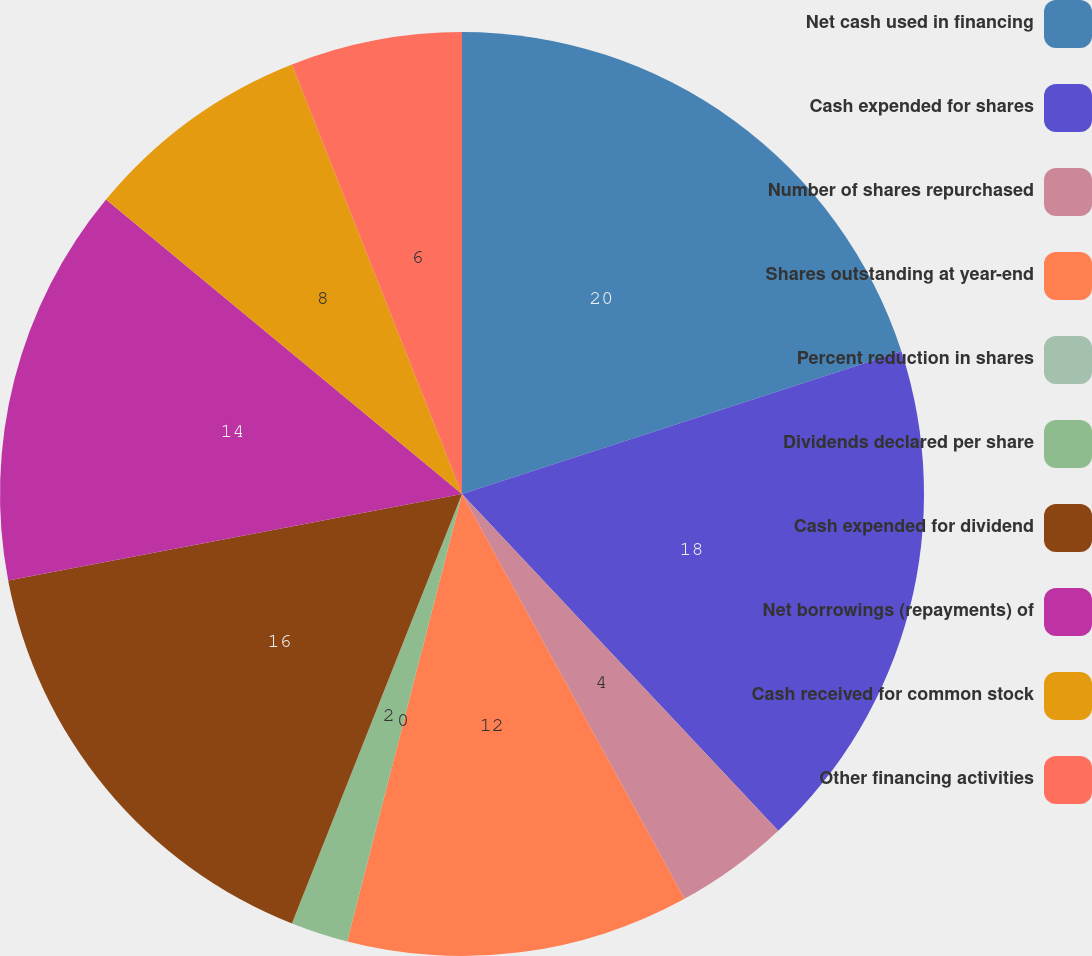Convert chart to OTSL. <chart><loc_0><loc_0><loc_500><loc_500><pie_chart><fcel>Net cash used in financing<fcel>Cash expended for shares<fcel>Number of shares repurchased<fcel>Shares outstanding at year-end<fcel>Percent reduction in shares<fcel>Dividends declared per share<fcel>Cash expended for dividend<fcel>Net borrowings (repayments) of<fcel>Cash received for common stock<fcel>Other financing activities<nl><fcel>20.0%<fcel>18.0%<fcel>4.0%<fcel>12.0%<fcel>0.0%<fcel>2.0%<fcel>16.0%<fcel>14.0%<fcel>8.0%<fcel>6.0%<nl></chart> 